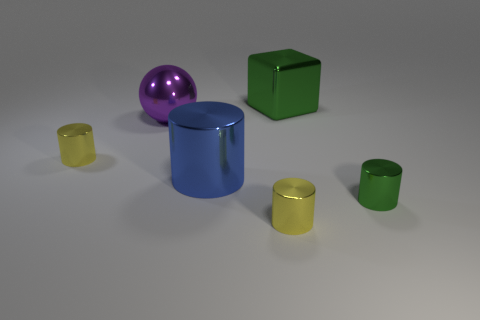Are there any tiny metallic things of the same color as the large shiny block?
Offer a very short reply. Yes. The large purple thing is what shape?
Give a very brief answer. Sphere. What is the color of the big object that is in front of the yellow cylinder behind the large cylinder?
Give a very brief answer. Blue. What is the size of the green metal thing that is behind the tiny green cylinder?
Provide a succinct answer. Large. Is there a yellow cube that has the same material as the large cylinder?
Provide a succinct answer. No. What number of green shiny things have the same shape as the blue shiny thing?
Provide a short and direct response. 1. What is the shape of the tiny shiny thing that is right of the large thing that is behind the big object to the left of the big blue shiny thing?
Provide a short and direct response. Cylinder. There is a cylinder that is left of the large metal cube and in front of the blue metallic thing; what is its material?
Your answer should be very brief. Metal. There is a metal cylinder that is behind the blue metallic object; is its size the same as the large purple metallic ball?
Make the answer very short. No. Is the number of big things behind the big green cube greater than the number of large purple balls that are on the right side of the blue cylinder?
Give a very brief answer. No. 